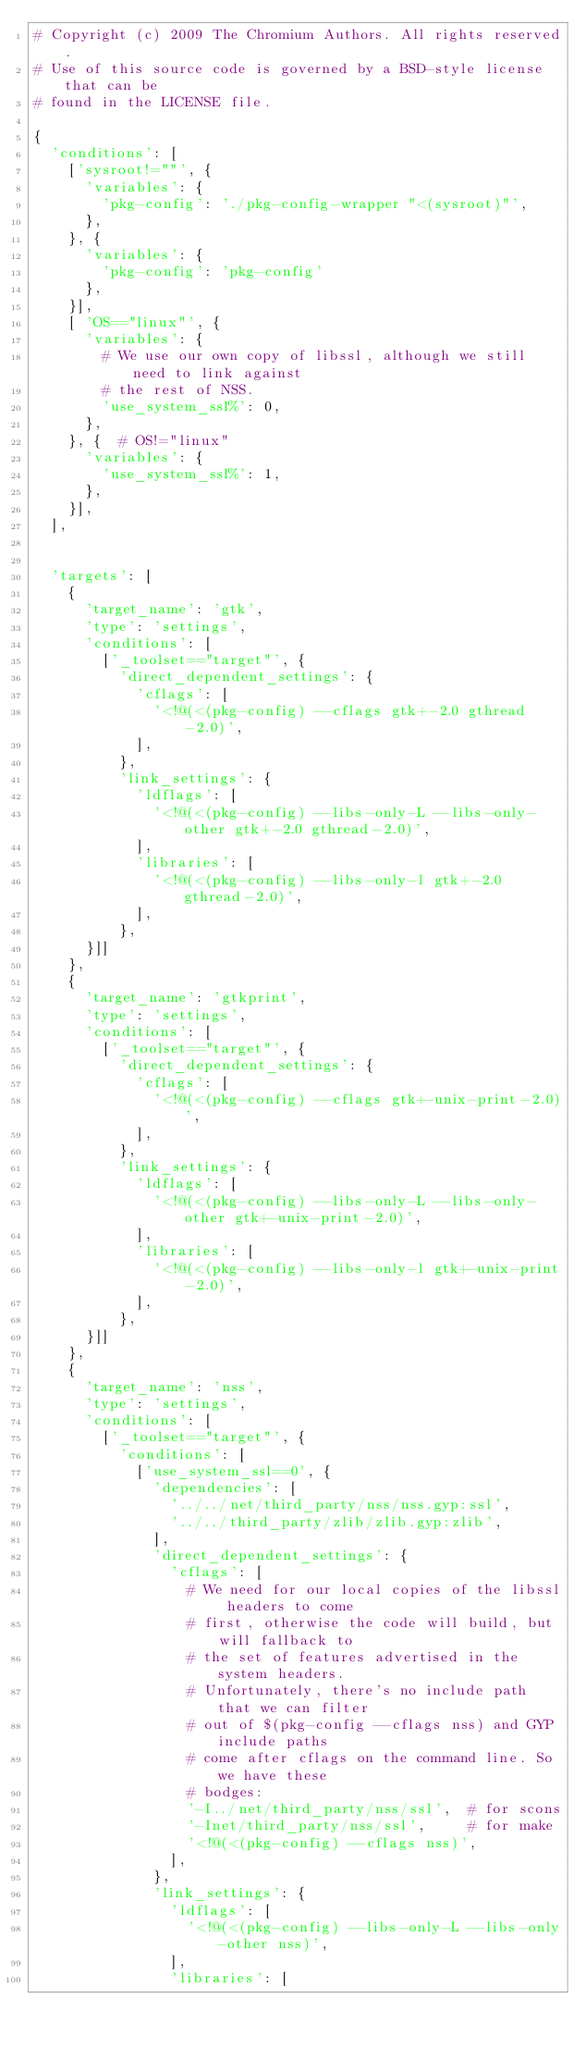Convert code to text. <code><loc_0><loc_0><loc_500><loc_500><_Python_># Copyright (c) 2009 The Chromium Authors. All rights reserved.
# Use of this source code is governed by a BSD-style license that can be
# found in the LICENSE file.

{
  'conditions': [
    ['sysroot!=""', {
      'variables': {
        'pkg-config': './pkg-config-wrapper "<(sysroot)"',
      },
    }, {
      'variables': {
        'pkg-config': 'pkg-config'
      },
    }],
    [ 'OS=="linux"', {
      'variables': {
        # We use our own copy of libssl, although we still need to link against
        # the rest of NSS.
        'use_system_ssl%': 0,
      },
    }, {  # OS!="linux"
      'variables': {
        'use_system_ssl%': 1,
      },
    }],
  ],


  'targets': [
    {
      'target_name': 'gtk',
      'type': 'settings',
      'conditions': [
        ['_toolset=="target"', {
          'direct_dependent_settings': {
            'cflags': [
              '<!@(<(pkg-config) --cflags gtk+-2.0 gthread-2.0)',
            ],
          },
          'link_settings': {
            'ldflags': [
              '<!@(<(pkg-config) --libs-only-L --libs-only-other gtk+-2.0 gthread-2.0)',
            ],
            'libraries': [
              '<!@(<(pkg-config) --libs-only-l gtk+-2.0 gthread-2.0)',
            ],
          },
      }]]
    },
    {
      'target_name': 'gtkprint',
      'type': 'settings',
      'conditions': [
        ['_toolset=="target"', {
          'direct_dependent_settings': {
            'cflags': [
              '<!@(<(pkg-config) --cflags gtk+-unix-print-2.0)',
            ],
          },
          'link_settings': {
            'ldflags': [
              '<!@(<(pkg-config) --libs-only-L --libs-only-other gtk+-unix-print-2.0)',
            ],
            'libraries': [
              '<!@(<(pkg-config) --libs-only-l gtk+-unix-print-2.0)',
            ],
          },
      }]]
    },
    {
      'target_name': 'nss',
      'type': 'settings',
      'conditions': [
        ['_toolset=="target"', {
          'conditions': [
            ['use_system_ssl==0', {
              'dependencies': [
                '../../net/third_party/nss/nss.gyp:ssl',
                '../../third_party/zlib/zlib.gyp:zlib',
              ],
              'direct_dependent_settings': {
                'cflags': [
                  # We need for our local copies of the libssl headers to come
                  # first, otherwise the code will build, but will fallback to
                  # the set of features advertised in the system headers.
                  # Unfortunately, there's no include path that we can filter
                  # out of $(pkg-config --cflags nss) and GYP include paths
                  # come after cflags on the command line. So we have these
                  # bodges:
                  '-I../net/third_party/nss/ssl',  # for scons
                  '-Inet/third_party/nss/ssl',     # for make
                  '<!@(<(pkg-config) --cflags nss)',
                ],
              },
              'link_settings': {
                'ldflags': [
                  '<!@(<(pkg-config) --libs-only-L --libs-only-other nss)',
                ],
                'libraries': [</code> 